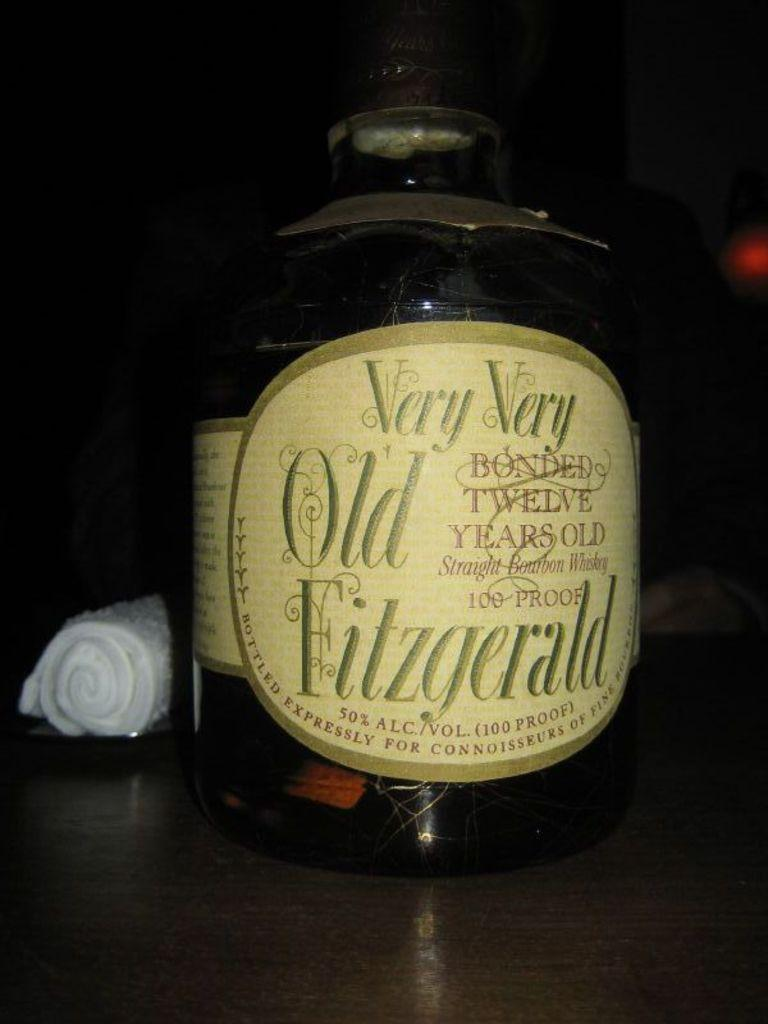What is on the surface in the image? There is a bottle and a white object on the surface. What can be seen on the bottle? The bottle has a sticker on it. How would you describe the background in the image? The background is dark. How much does the box weigh in the image? There is no box present in the image, so its weight cannot be determined. 